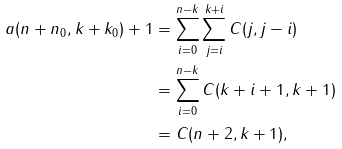Convert formula to latex. <formula><loc_0><loc_0><loc_500><loc_500>a ( n + n _ { 0 } , k + k _ { 0 } ) + 1 & = \sum _ { i = 0 } ^ { n - k } \sum _ { j = i } ^ { k + i } C ( j , j - i ) \\ & = \sum _ { i = 0 } ^ { n - k } C ( k + i + 1 , k + 1 ) \\ & = C ( n + 2 , k + 1 ) ,</formula> 